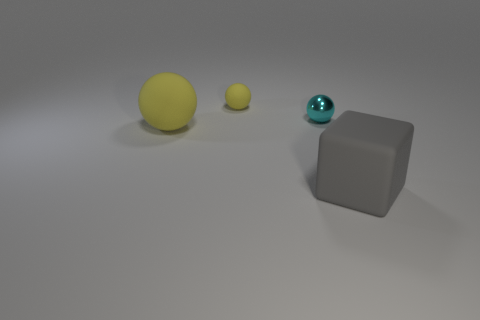There is a matte thing that is in front of the yellow sphere in front of the small cyan ball; what is its color? The matte object positioned in front of the yellow sphere, ahead of the smaller cyan-colored ball, appears to be gray. 